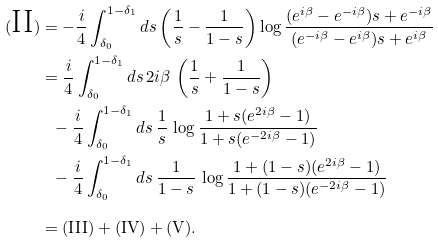<formula> <loc_0><loc_0><loc_500><loc_500>( \text {II} ) & = - \frac { i } { 4 } \int ^ { 1 - \delta _ { 1 } } _ { \delta _ { 0 } } d s \left ( \frac { 1 } { s } - \frac { 1 } { 1 - s } \right ) \log \frac { ( e ^ { i \beta } - e ^ { - i \beta } ) s + e ^ { - i \beta } } { ( e ^ { - i \beta } - e ^ { i \beta } ) s + e ^ { i \beta } } \\ & = \frac { i } { 4 } \int ^ { 1 - \delta _ { 1 } } _ { \delta _ { 0 } } d s \, 2 i \beta \, \left ( \frac { 1 } { s } + \frac { 1 } { 1 - s } \right ) \\ & \ \ - \frac { i } { 4 } \int ^ { 1 - \delta _ { 1 } } _ { \delta _ { 0 } } d s \, \frac { 1 } { s } \, \log \frac { 1 + s ( e ^ { 2 i \beta } - 1 ) } { 1 + s ( e ^ { - 2 i \beta } - 1 ) } \\ & \ \ - \frac { i } { 4 } \int ^ { 1 - \delta _ { 1 } } _ { \delta _ { 0 } } d s \, \frac { 1 } { 1 - s } \, \log \frac { 1 + ( 1 - s ) ( e ^ { 2 i \beta } - 1 ) } { 1 + ( 1 - s ) ( e ^ { - 2 i \beta } - 1 ) } \\ & = ( \text {III} ) + ( \text {IV} ) + ( \text {V} ) .</formula> 